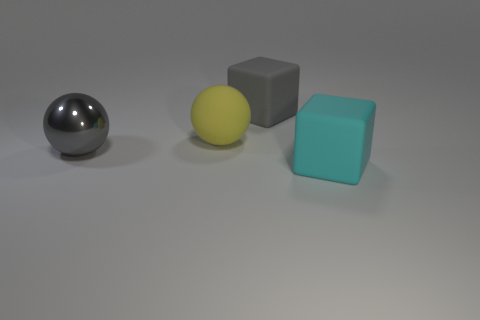Add 3 gray blocks. How many objects exist? 7 Subtract 0 red balls. How many objects are left? 4 Subtract all big cubes. Subtract all matte spheres. How many objects are left? 1 Add 3 gray blocks. How many gray blocks are left? 4 Add 1 big matte things. How many big matte things exist? 4 